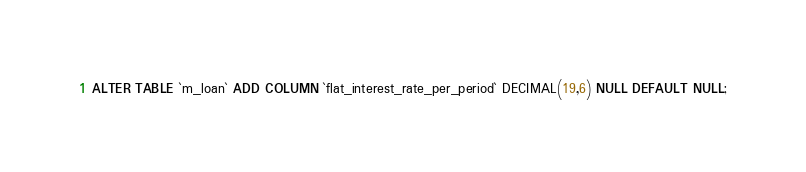<code> <loc_0><loc_0><loc_500><loc_500><_SQL_>ALTER TABLE `m_loan` ADD COLUMN `flat_interest_rate_per_period` DECIMAL(19,6) NULL DEFAULT NULL;</code> 